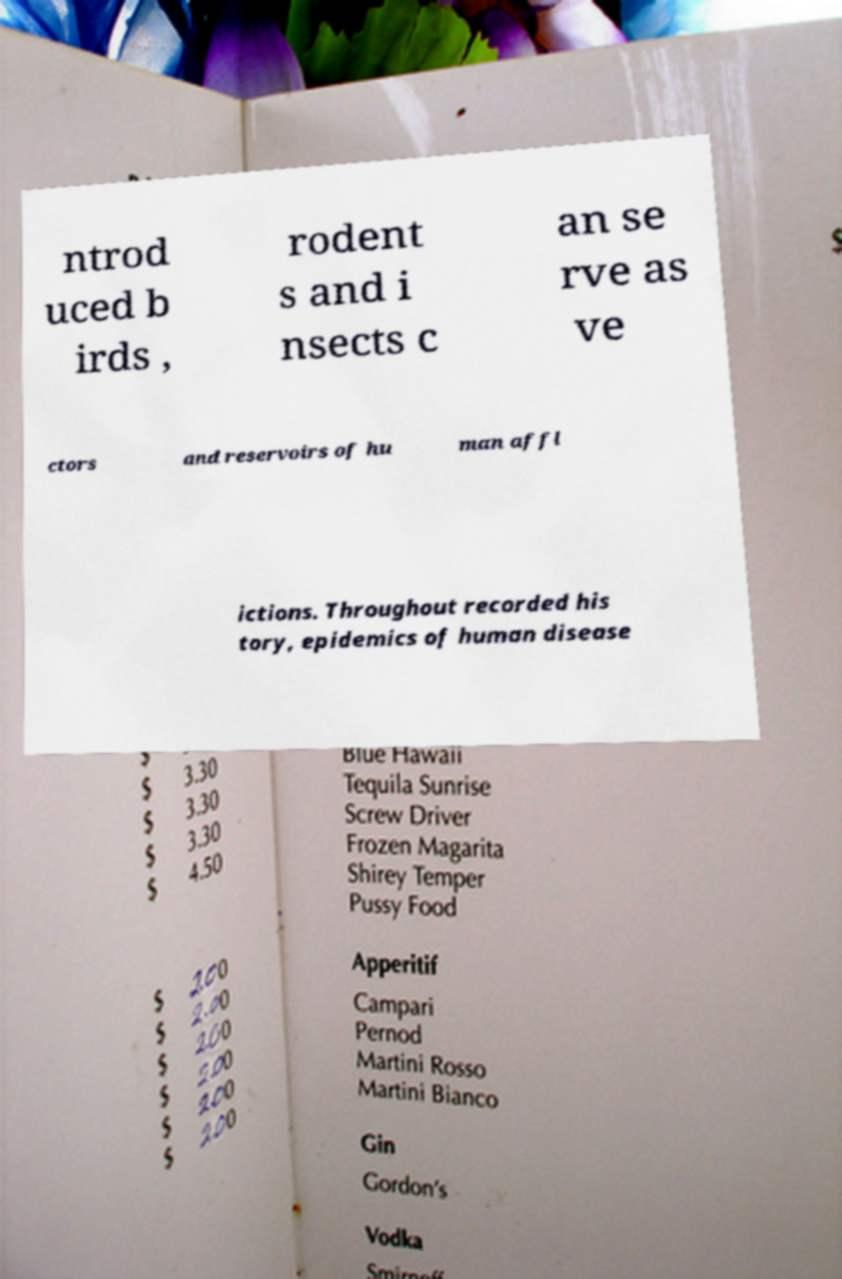Could you extract and type out the text from this image? ntrod uced b irds , rodent s and i nsects c an se rve as ve ctors and reservoirs of hu man affl ictions. Throughout recorded his tory, epidemics of human disease 